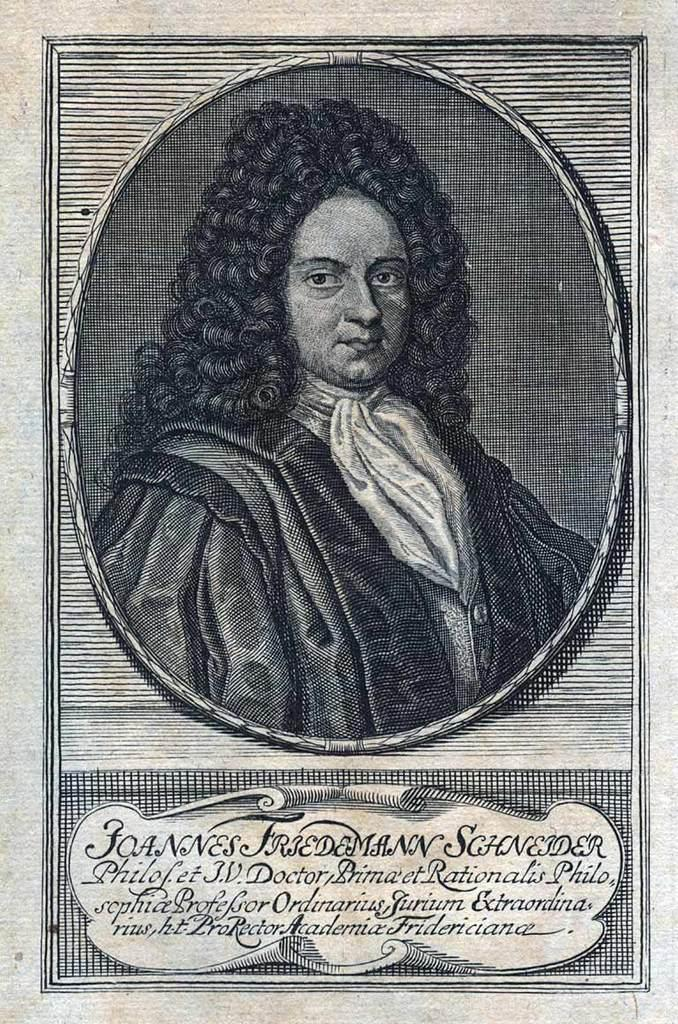<image>
Describe the image concisely. An old black and white illustration of Joannes Friedemann Schneider. 